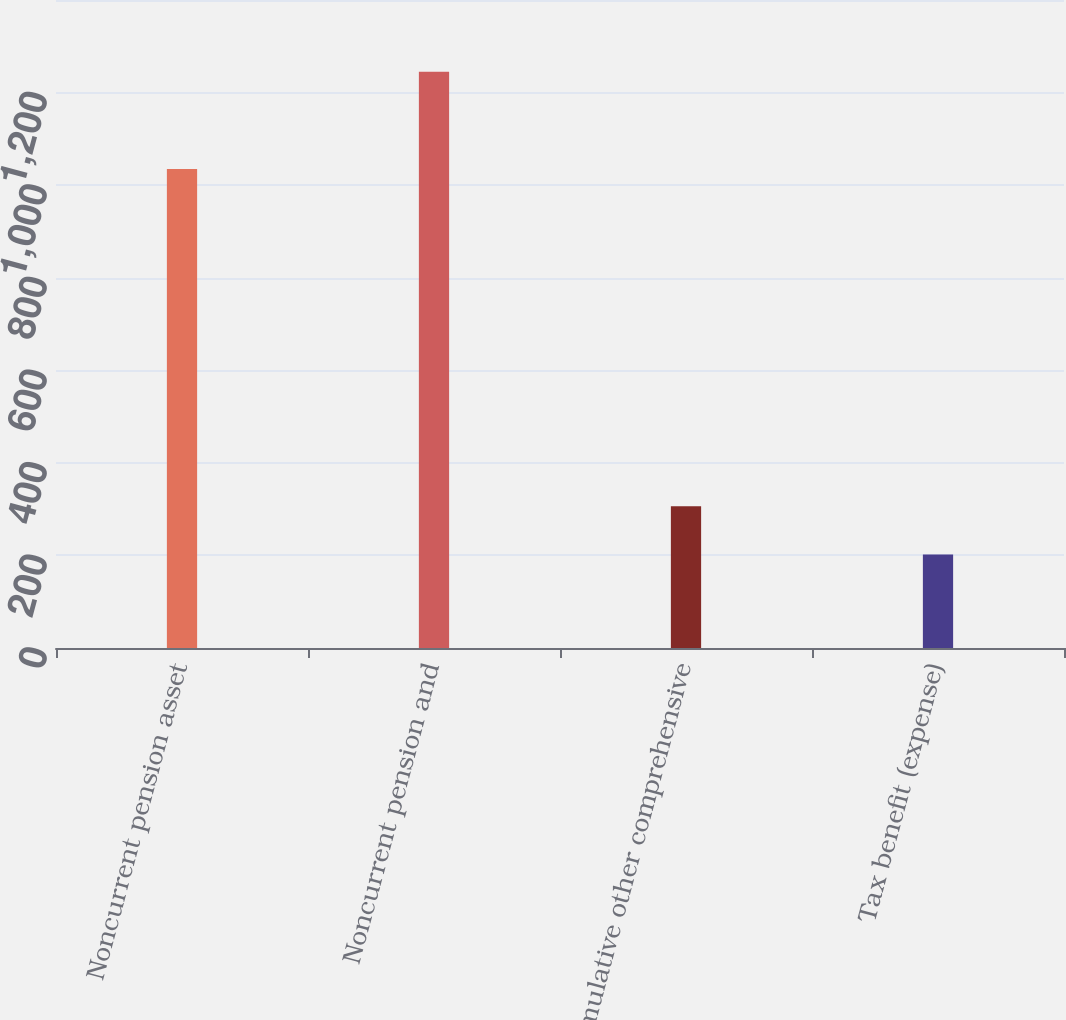Convert chart. <chart><loc_0><loc_0><loc_500><loc_500><bar_chart><fcel>Noncurrent pension asset<fcel>Noncurrent pension and<fcel>Cumulative other comprehensive<fcel>Tax benefit (expense)<nl><fcel>1035<fcel>1245<fcel>306.3<fcel>202<nl></chart> 